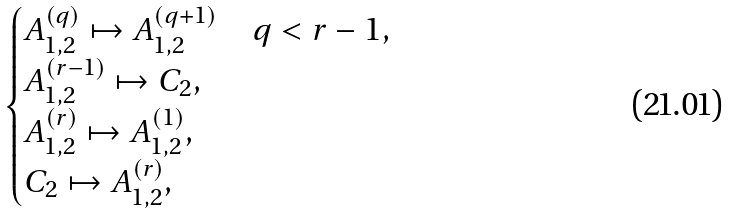Convert formula to latex. <formula><loc_0><loc_0><loc_500><loc_500>\begin{cases} A _ { 1 , 2 } ^ { ( q ) } \mapsto A _ { 1 , 2 } ^ { ( q + 1 ) } & q < r - 1 , \\ A _ { 1 , 2 } ^ { ( r - 1 ) } \mapsto C _ { 2 } , \\ A _ { 1 , 2 } ^ { ( r ) } \mapsto A _ { 1 , 2 } ^ { ( 1 ) } , \\ C _ { 2 } \mapsto A _ { 1 , 2 } ^ { ( r ) } , \end{cases}</formula> 